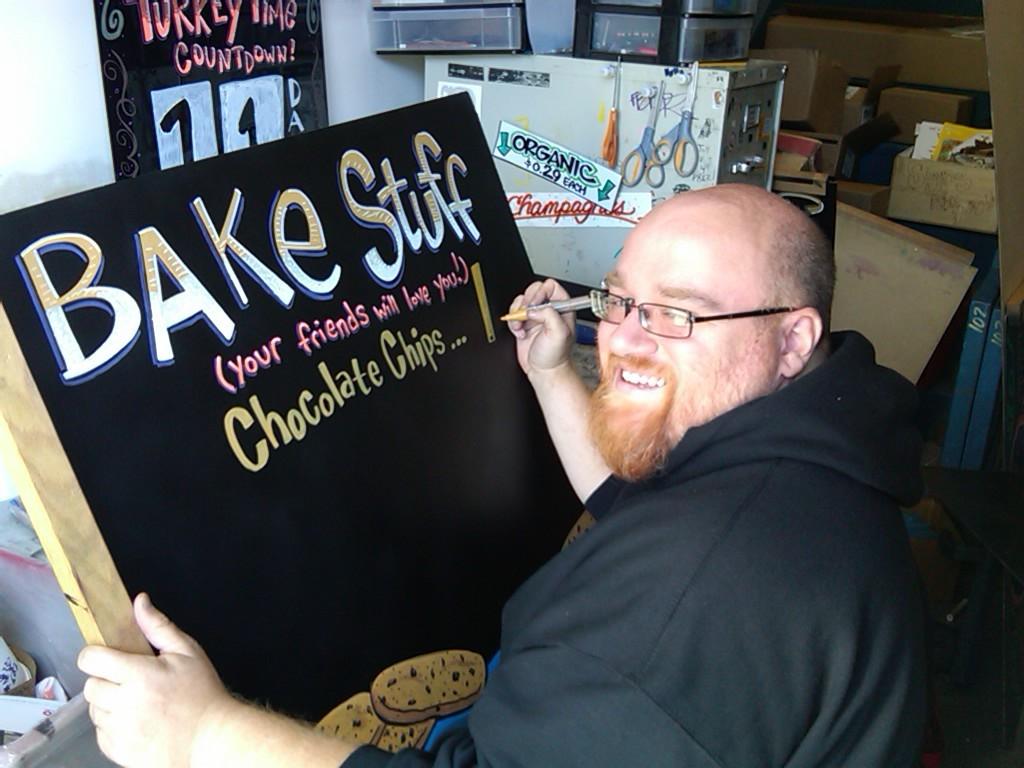Whats on the illboard?
Give a very brief answer. Bake stuff. 